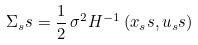Convert formula to latex. <formula><loc_0><loc_0><loc_500><loc_500>\Sigma _ { s } s = \frac { 1 } { 2 } \, \sigma ^ { 2 } H ^ { - 1 } \left ( x _ { s } s , u _ { s } s \right )</formula> 